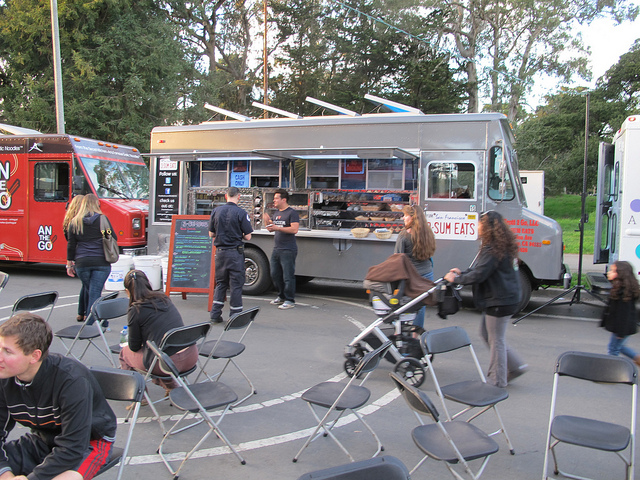Read all the text in this image. an THE GO NEO EATS A 